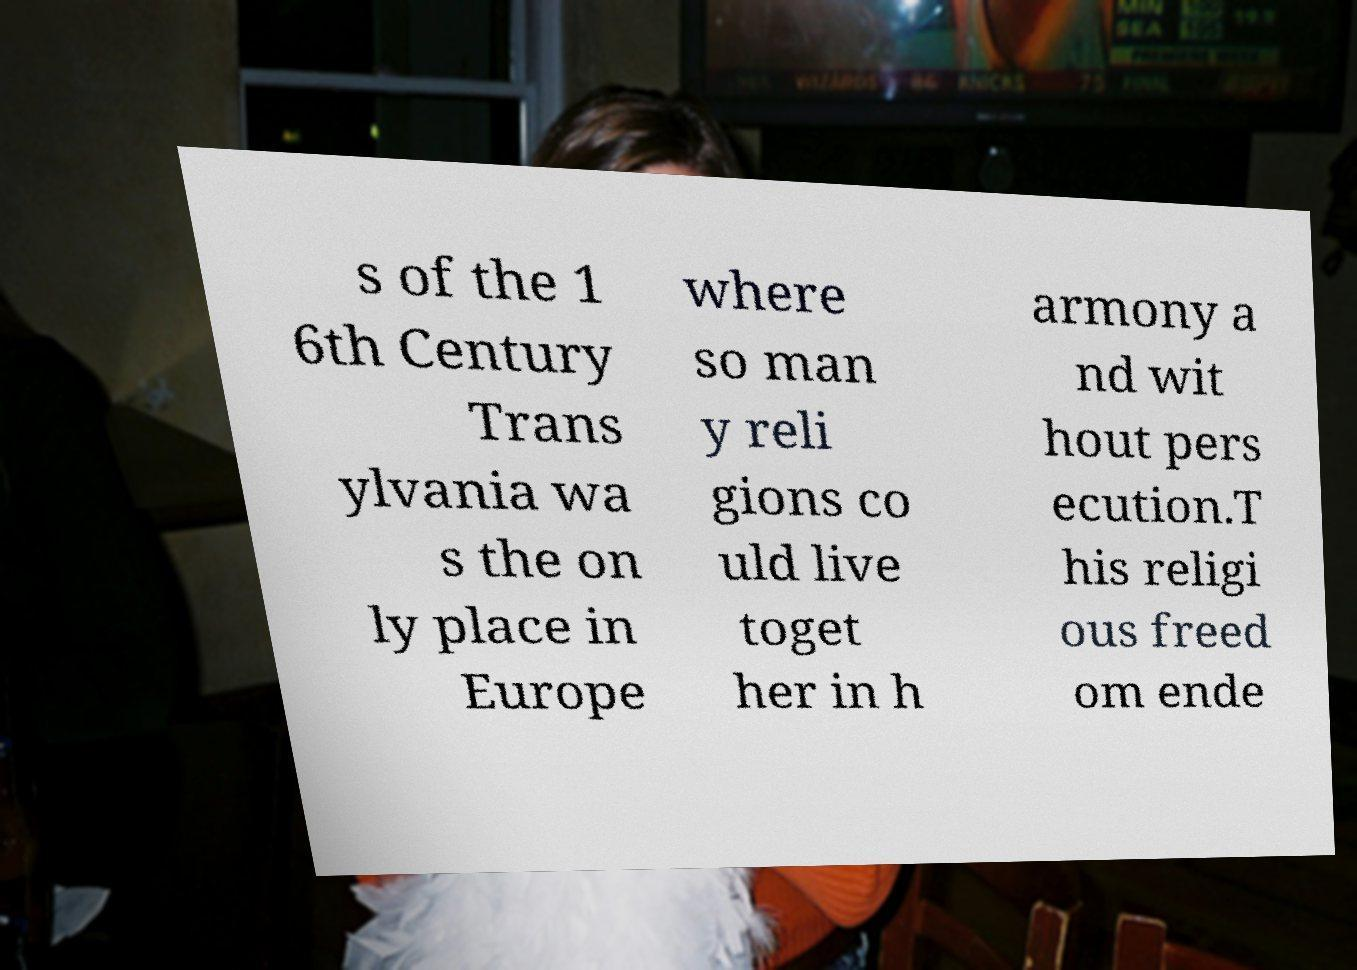Could you assist in decoding the text presented in this image and type it out clearly? s of the 1 6th Century Trans ylvania wa s the on ly place in Europe where so man y reli gions co uld live toget her in h armony a nd wit hout pers ecution.T his religi ous freed om ende 